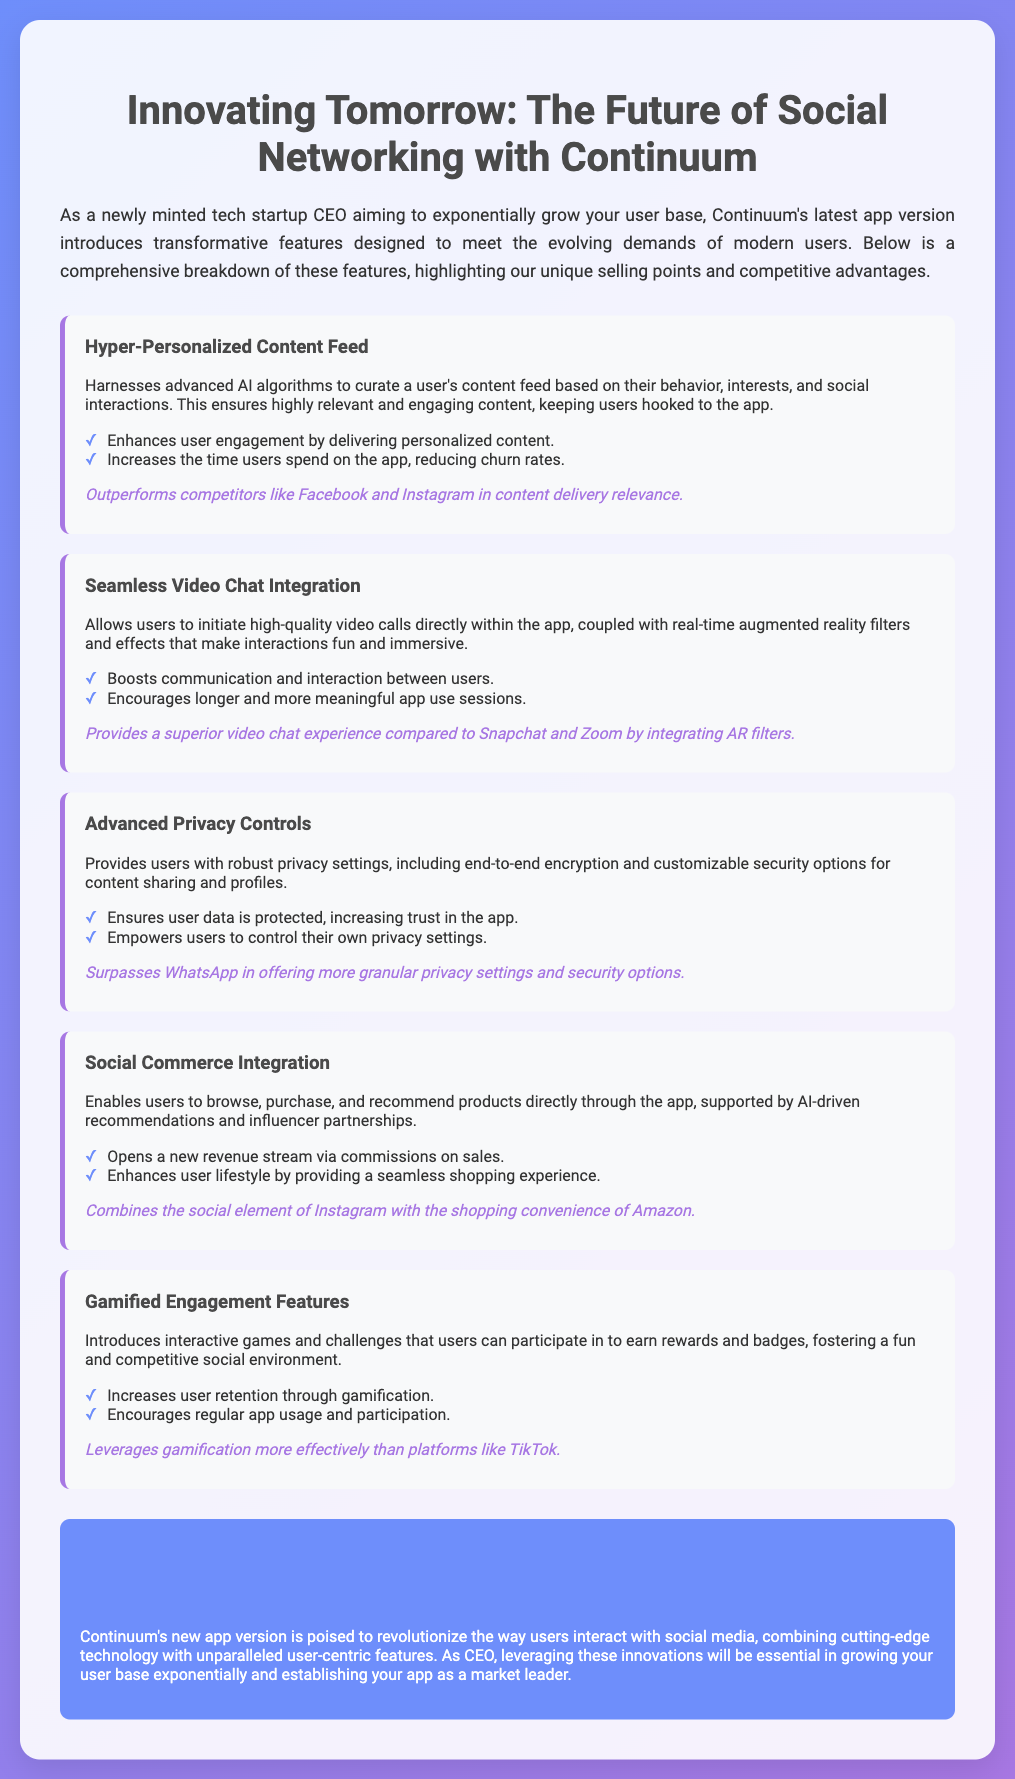What is the name of the app? The app is called Continuum, as mentioned in the title of the document.
Answer: Continuum What feature enhances user engagement? The feature that enhances user engagement is referred to as the Hyper-Personalized Content Feed.
Answer: Hyper-Personalized Content Feed Which competitive advantage is mentioned for Advanced Privacy Controls? The competitive advantage for Advanced Privacy Controls is specified as surpassing WhatsApp in offering more granular privacy settings.
Answer: Surpasses WhatsApp How many gamified engagement features are introduced? The document indicates that multiple gamified engagement features are introduced, particularly referring to interactive games and challenges.
Answer: Multiple What technology does the Seamless Video Chat Integration utilize? The technology utilized in the Seamless Video Chat Integration includes real-time augmented reality filters and effects.
Answer: Augmented reality filters What benefits does Social Commerce Integration provide? The benefits include opening a new revenue stream via commissions and enhancing user lifestyle with seamless shopping.
Answer: New revenue stream & seamless shopping Which feature is designed to reduce churn rates? The feature designed to reduce churn rates is the Hyper-Personalized Content Feed, which keeps users engaged.
Answer: Hyper-Personalized Content Feed What is the primary goal of Continuum's new app version? The primary goal is to revolutionize the way users interact with social media while growing the user base exponentially.
Answer: Revolutionize interactions & grow user base 